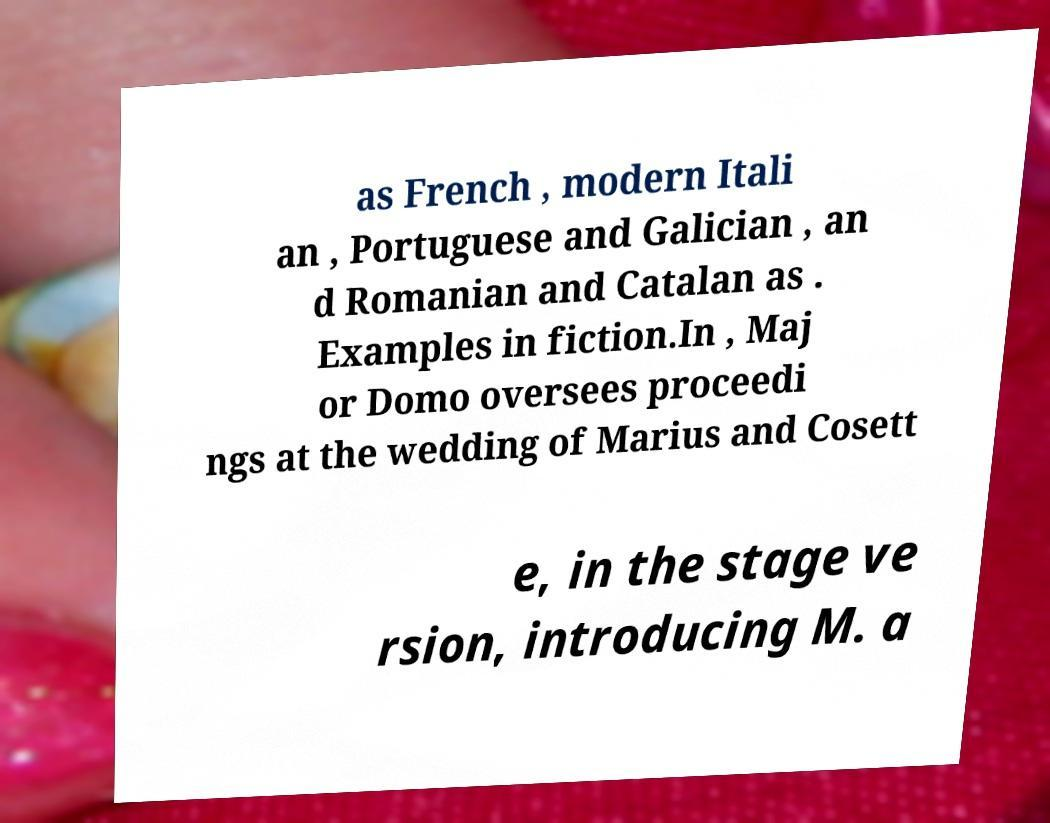What messages or text are displayed in this image? I need them in a readable, typed format. as French , modern Itali an , Portuguese and Galician , an d Romanian and Catalan as . Examples in fiction.In , Maj or Domo oversees proceedi ngs at the wedding of Marius and Cosett e, in the stage ve rsion, introducing M. a 